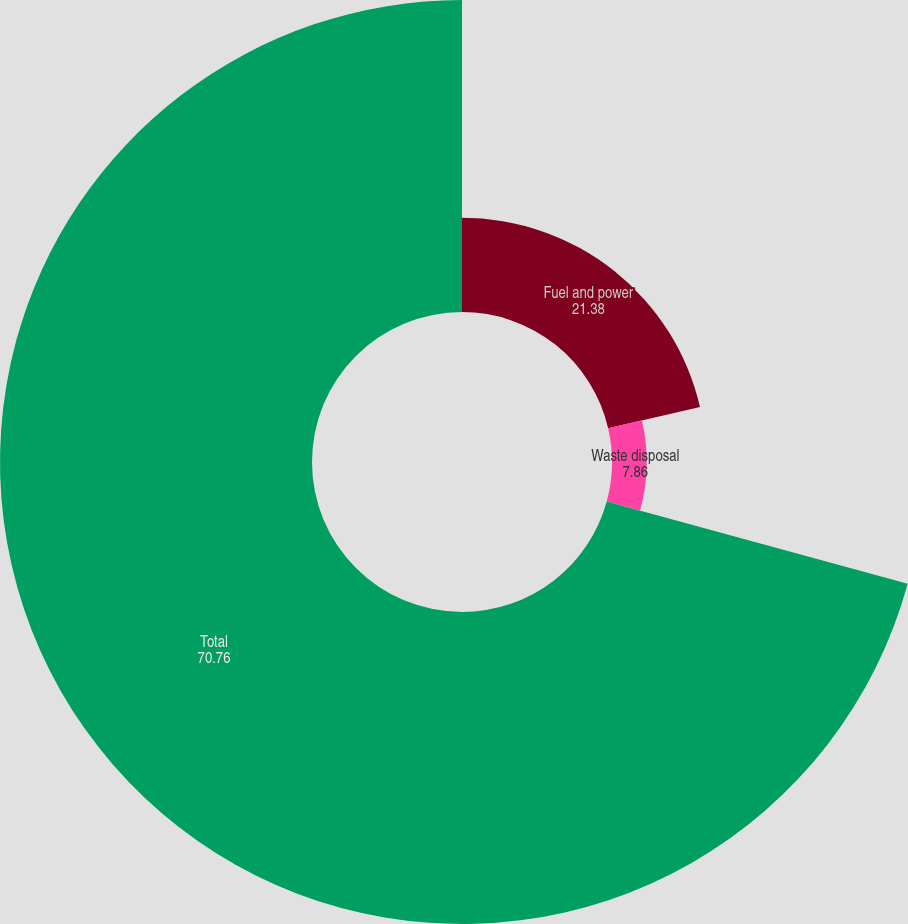<chart> <loc_0><loc_0><loc_500><loc_500><pie_chart><fcel>Fuel and power<fcel>Waste disposal<fcel>Total<nl><fcel>21.38%<fcel>7.86%<fcel>70.76%<nl></chart> 